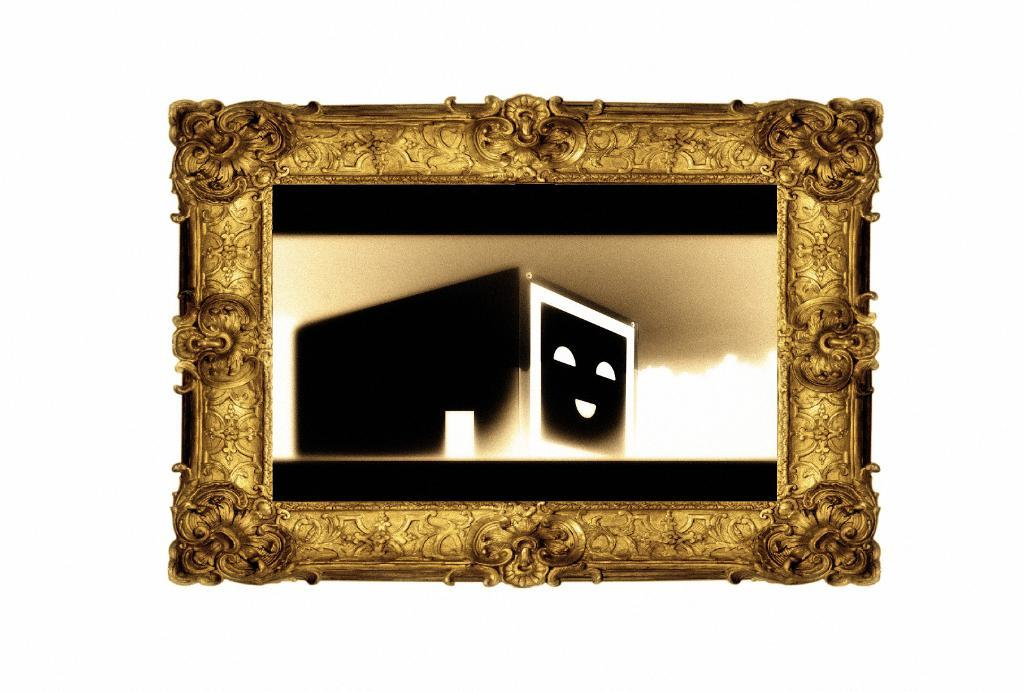What is the main subject in the center of the image? There is a photo frame in the center of the image. What can be seen inside the photo frame? There are objects in the photo frame. What color is the background of the image? The background of the image is white. What type of feast is being prepared in the image? There is no indication of a feast or any food preparation in the image; it primarily features a photo frame with objects inside. 